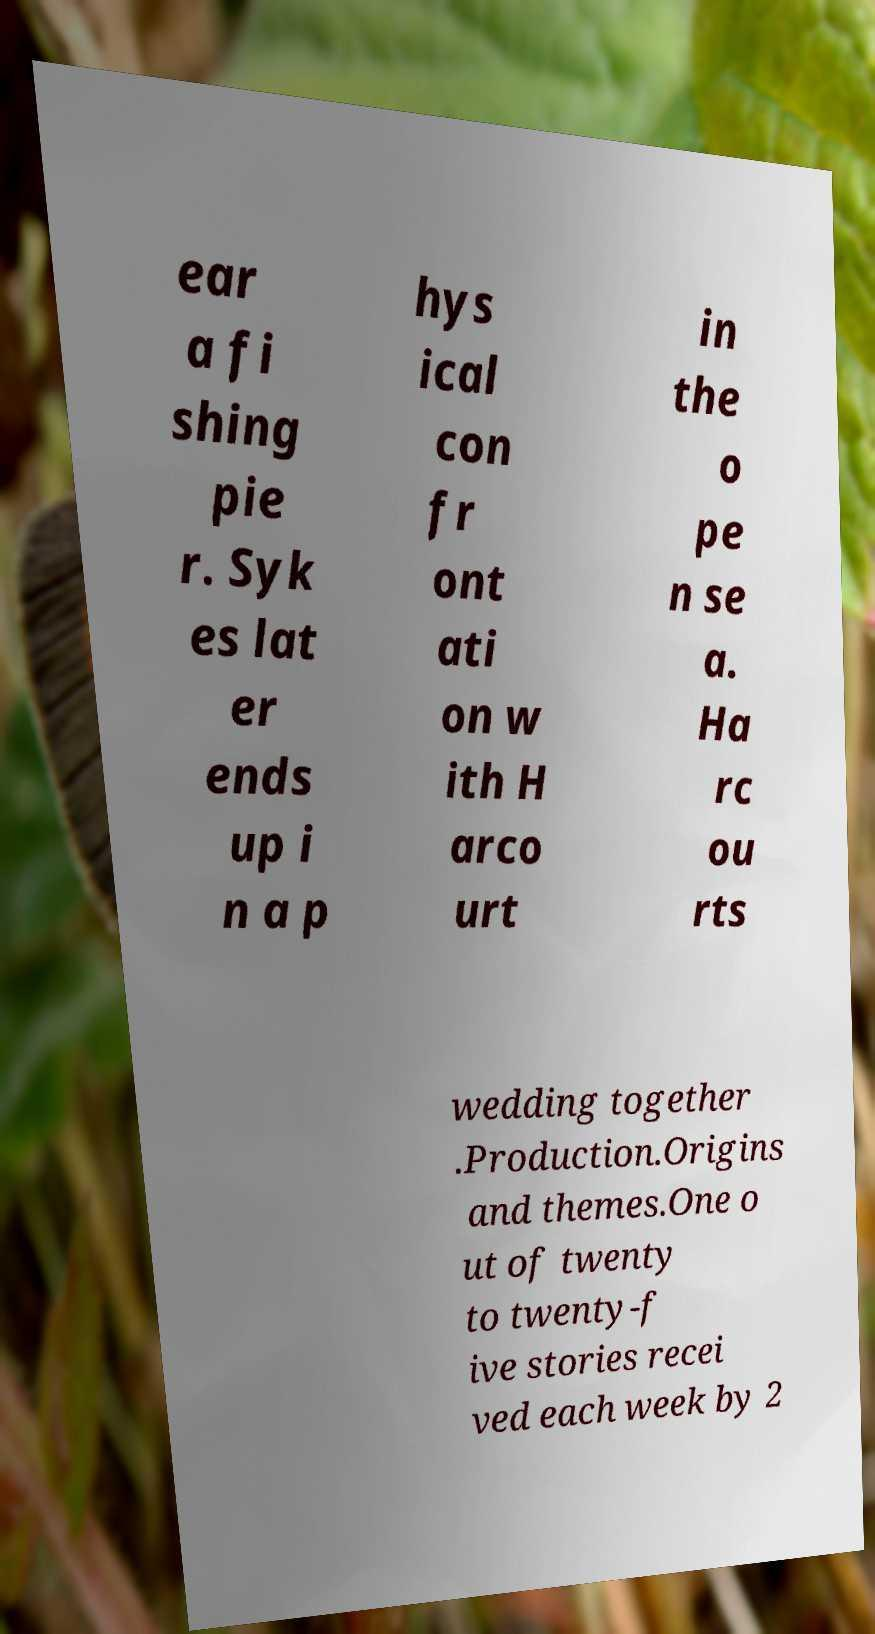Can you read and provide the text displayed in the image?This photo seems to have some interesting text. Can you extract and type it out for me? ear a fi shing pie r. Syk es lat er ends up i n a p hys ical con fr ont ati on w ith H arco urt in the o pe n se a. Ha rc ou rts wedding together .Production.Origins and themes.One o ut of twenty to twenty-f ive stories recei ved each week by 2 